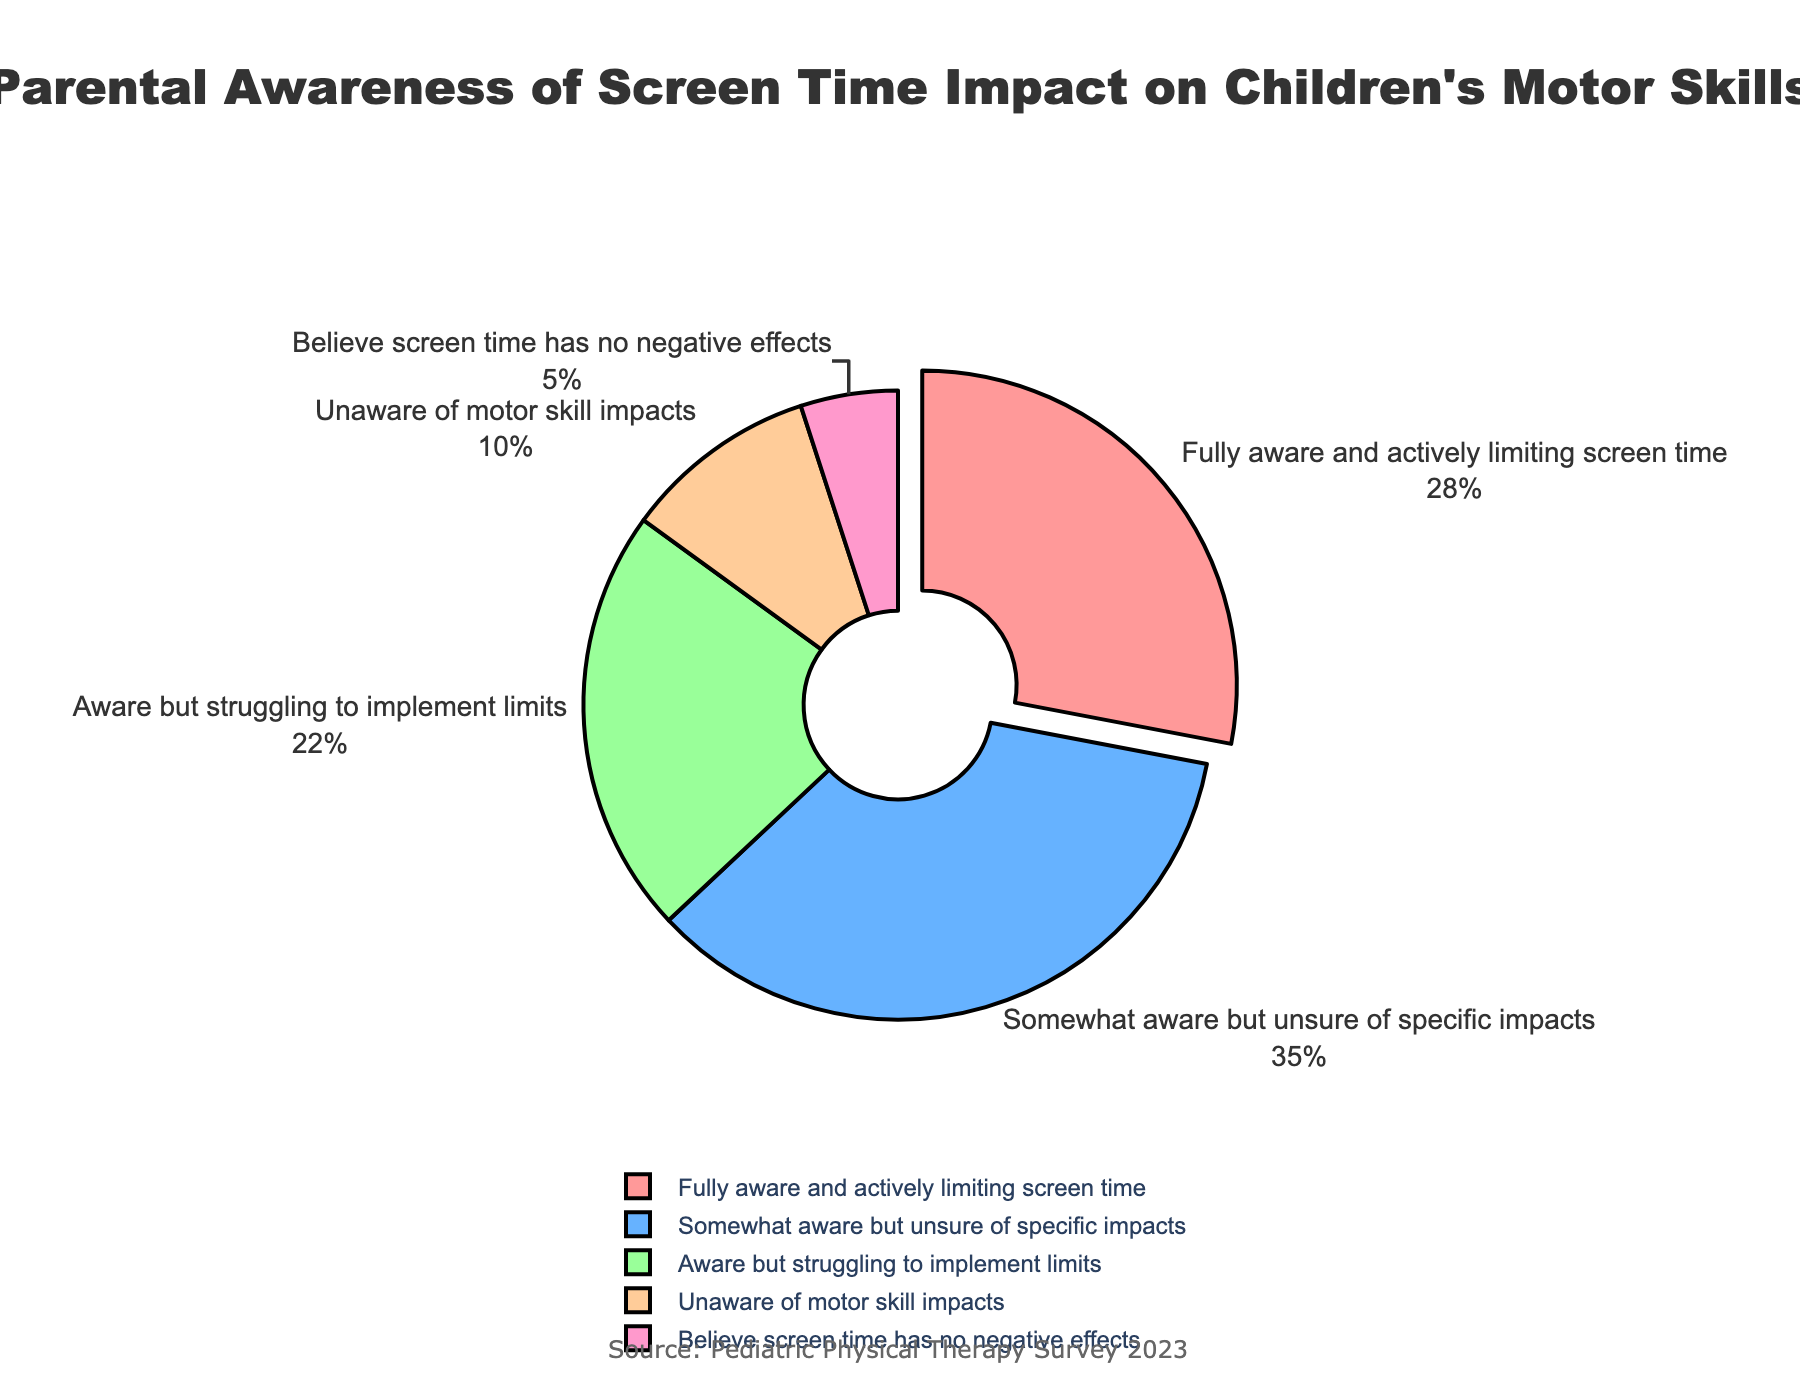What percentage of parents are fully aware and actively limiting screen time? To find the percentage of parents fully aware and actively limiting screen time, we refer to the section of the pie chart labeled "Fully aware and actively limiting screen time" and note the percentage. This value is 28%.
Answer: 28% How many parents are at least somewhat aware of the impact of screen time but have varying levels of action? Sum the percentages of parents who are "Fully aware and actively limiting screen time" (28%), "Somewhat aware but unsure of specific impacts" (35%), and "Aware but struggling to implement limits" (22%). These percentages add up to 28% + 35% + 22% = 85%.
Answer: 85% What is the difference in percentage between parents who are unaware of motor skill impacts and those who believe screen time has no negative effects? The percentage of parents unaware of motor skill impacts is 10%, and the percentage of those who believe screen time has no negative effects is 5%. The difference is 10% - 5% = 5%.
Answer: 5% Which awareness level has the highest percentage? The pie chart shows different awareness levels with their associated percentages. The section with the largest percentage at 35% is labeled "Somewhat aware but unsure of specific impacts."
Answer: Somewhat aware but unsure of specific impacts What is the combined percentage of parents who are either unaware of or believe there are no negative effects of screen time? Sum the percentages of parents who are "Unaware of motor skill impacts" (10%) and those who "Believe screen time has no negative effects" (5%). The total is 10% + 5% = 15%.
Answer: 15% Compare the percentage of parents who are fully aware and actively limiting screen time to those who are aware but struggling to implement limits. The percentage of parents who are fully aware and actively limiting screen time is 28%, while the percentage of those who are aware but struggling to implement limits is 22%. The former is greater by 28% - 22% = 6%.
Answer: 6% What color represents the group of parents who are somewhat aware but unsure of specific impacts? By observing the pie chart, we look for the color associated with the segment labeled "Somewhat aware but unsure of specific impacts." It is represented in blue.
Answer: Blue How much larger is the percentage of parents who are somewhat aware but unsure of specific impacts compared to those who believe screen time has no negative effects? The percentage of parents who are somewhat aware but unsure of specific impacts is 35%, while those who believe screen time has no negative effects is 5%. The difference is 35% - 5% = 30%.
Answer: 30% 